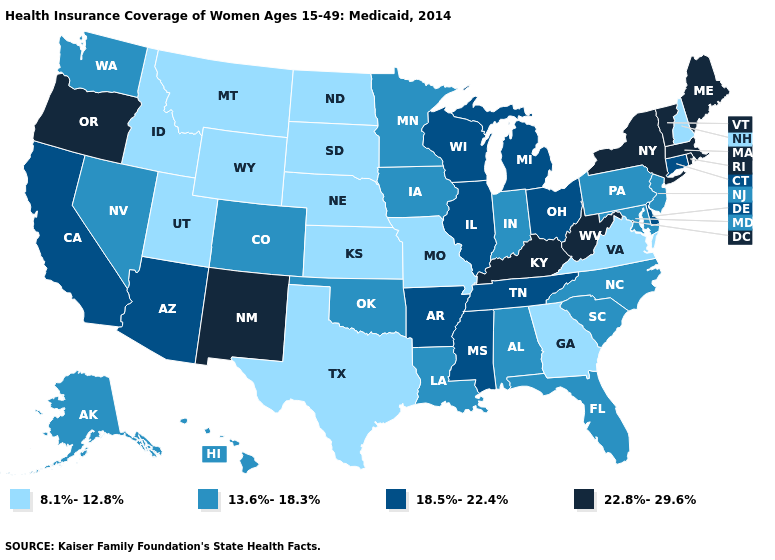Does the first symbol in the legend represent the smallest category?
Be succinct. Yes. What is the value of Washington?
Short answer required. 13.6%-18.3%. Does the map have missing data?
Write a very short answer. No. Does Montana have the highest value in the West?
Keep it brief. No. What is the lowest value in the USA?
Concise answer only. 8.1%-12.8%. Among the states that border Michigan , which have the highest value?
Be succinct. Ohio, Wisconsin. Among the states that border Virginia , does Kentucky have the highest value?
Write a very short answer. Yes. How many symbols are there in the legend?
Answer briefly. 4. What is the lowest value in states that border Arkansas?
Answer briefly. 8.1%-12.8%. Does New York have the same value as Louisiana?
Give a very brief answer. No. What is the lowest value in the Northeast?
Concise answer only. 8.1%-12.8%. What is the lowest value in the Northeast?
Give a very brief answer. 8.1%-12.8%. What is the value of Tennessee?
Be succinct. 18.5%-22.4%. Name the states that have a value in the range 18.5%-22.4%?
Quick response, please. Arizona, Arkansas, California, Connecticut, Delaware, Illinois, Michigan, Mississippi, Ohio, Tennessee, Wisconsin. Does Wyoming have the lowest value in the USA?
Answer briefly. Yes. 